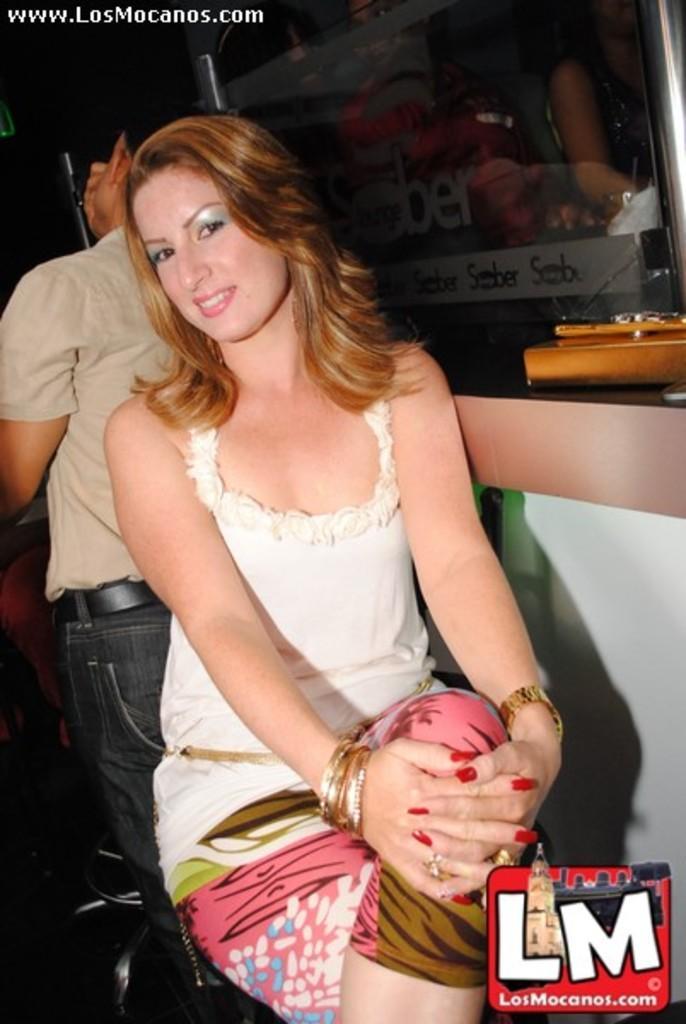Describe this image in one or two sentences. In this picture I can observe a woman sitting on the chair in the middle of the picture. Behind her I can observe a man. In the bottom right side I can observe a watermark. 